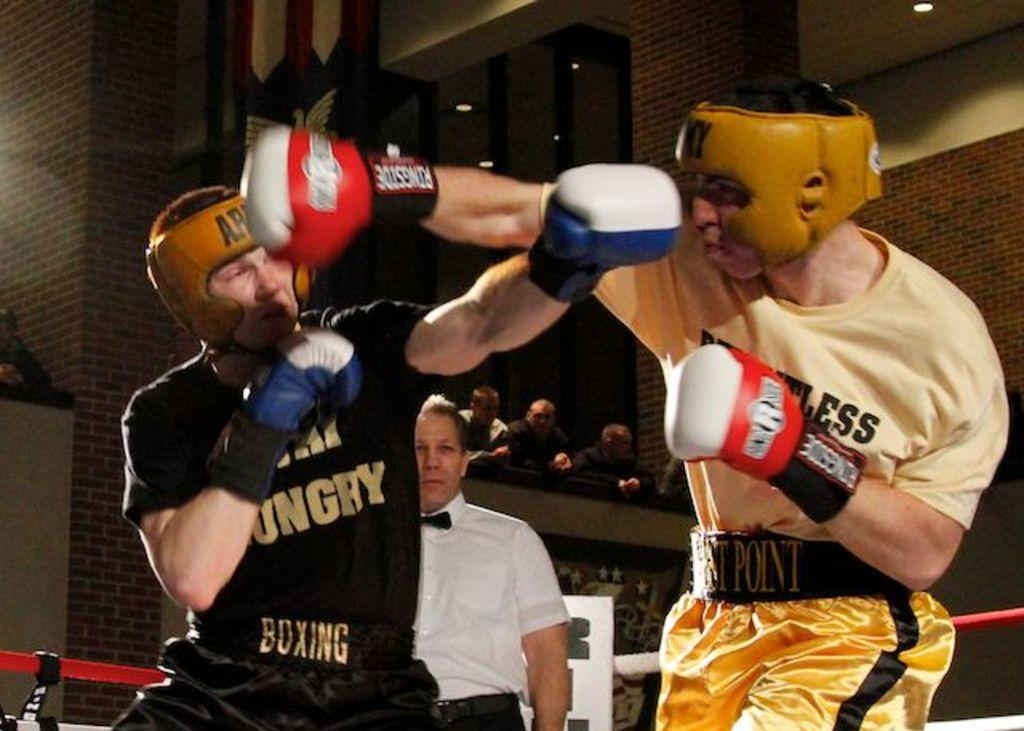What are the two persons in the image doing? The two persons in the image are boxing. Can you describe the person in the background? There is a person with a white shirt in the background. What else is present in the image besides the boxing match? The image includes lights and persons watching the boxing match. What type of team is the person with the scarf supporting in the image? There is no person with a scarf present in the image, and therefore no team affiliation can be determined. 